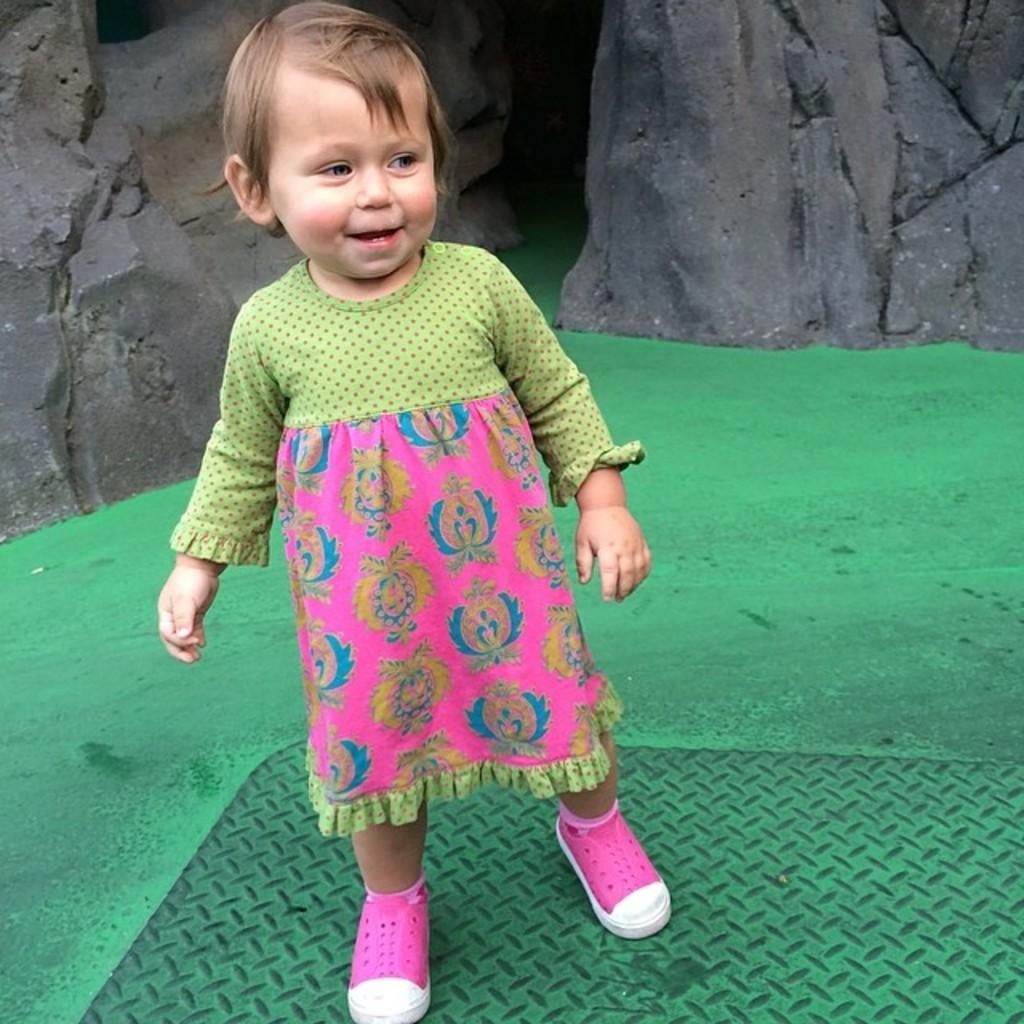Who is the main subject in the image? There is a girl in the image. What is the girl wearing? The girl is wearing a dress. Where is the girl standing? The girl is standing on the floor. What can be seen in the background of the image? There are rocks visible in the background of the image. What type of pet is the girl holding in the image? There is no pet visible in the image. What kind of building can be seen in the background of the image? There is no building present in the image; it features rocks in the background. 